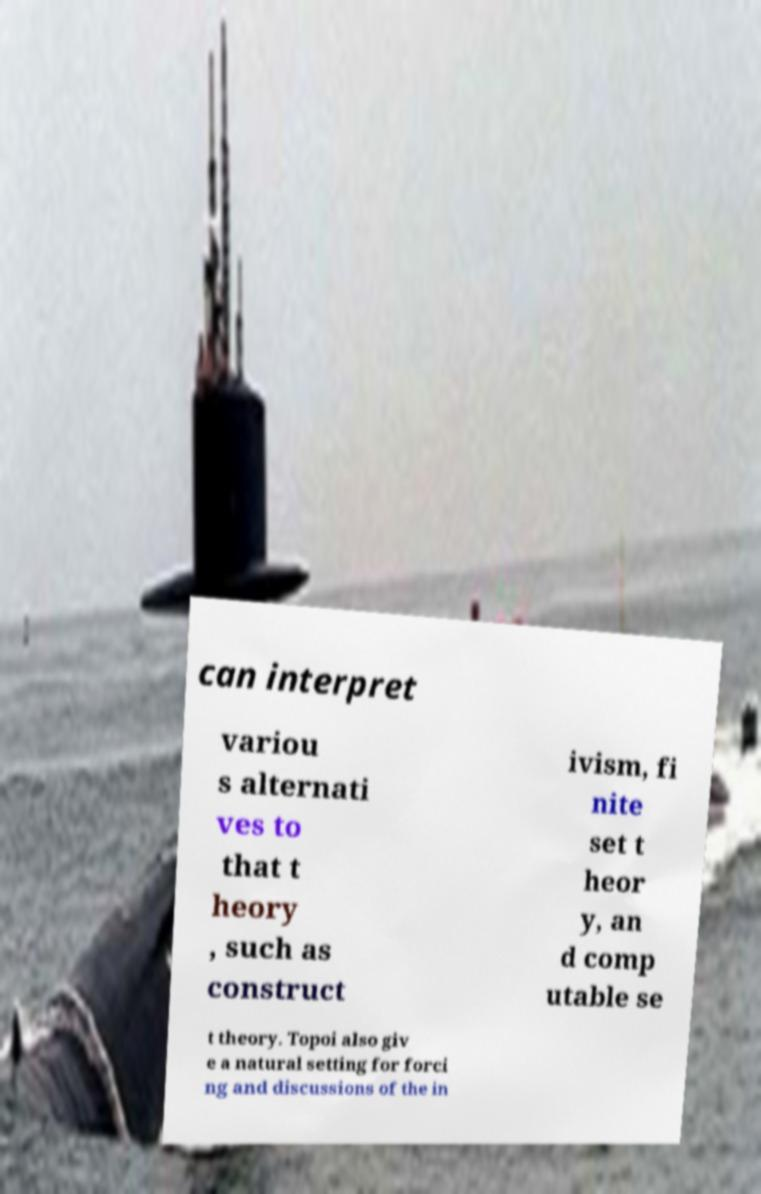What messages or text are displayed in this image? I need them in a readable, typed format. can interpret variou s alternati ves to that t heory , such as construct ivism, fi nite set t heor y, an d comp utable se t theory. Topoi also giv e a natural setting for forci ng and discussions of the in 